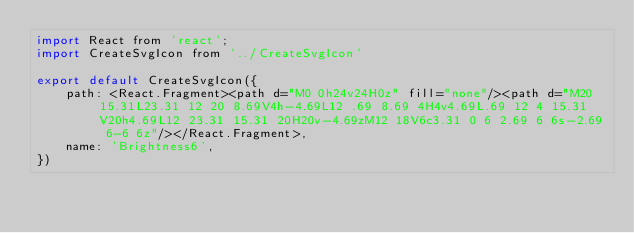Convert code to text. <code><loc_0><loc_0><loc_500><loc_500><_JavaScript_>import React from 'react';
import CreateSvgIcon from '../CreateSvgIcon'

export default CreateSvgIcon({
    path: <React.Fragment><path d="M0 0h24v24H0z" fill="none"/><path d="M20 15.31L23.31 12 20 8.69V4h-4.69L12 .69 8.69 4H4v4.69L.69 12 4 15.31V20h4.69L12 23.31 15.31 20H20v-4.69zM12 18V6c3.31 0 6 2.69 6 6s-2.69 6-6 6z"/></React.Fragment>,
    name: 'Brightness6',
})</code> 